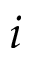<formula> <loc_0><loc_0><loc_500><loc_500>i</formula> 